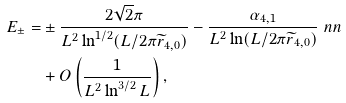<formula> <loc_0><loc_0><loc_500><loc_500>E _ { \pm } = & \pm \frac { 2 \sqrt { 2 } \pi } { L ^ { 2 } \ln ^ { 1 / 2 } ( L / 2 \pi \widetilde { r } _ { 4 , 0 } ) } - \frac { \alpha _ { 4 , 1 } } { L ^ { 2 } \ln ( L / 2 \pi \widetilde { r } _ { 4 , 0 } ) } \ n n \\ & + O \left ( \frac { 1 } { L ^ { 2 } \ln ^ { 3 / 2 } L } \right ) ,</formula> 